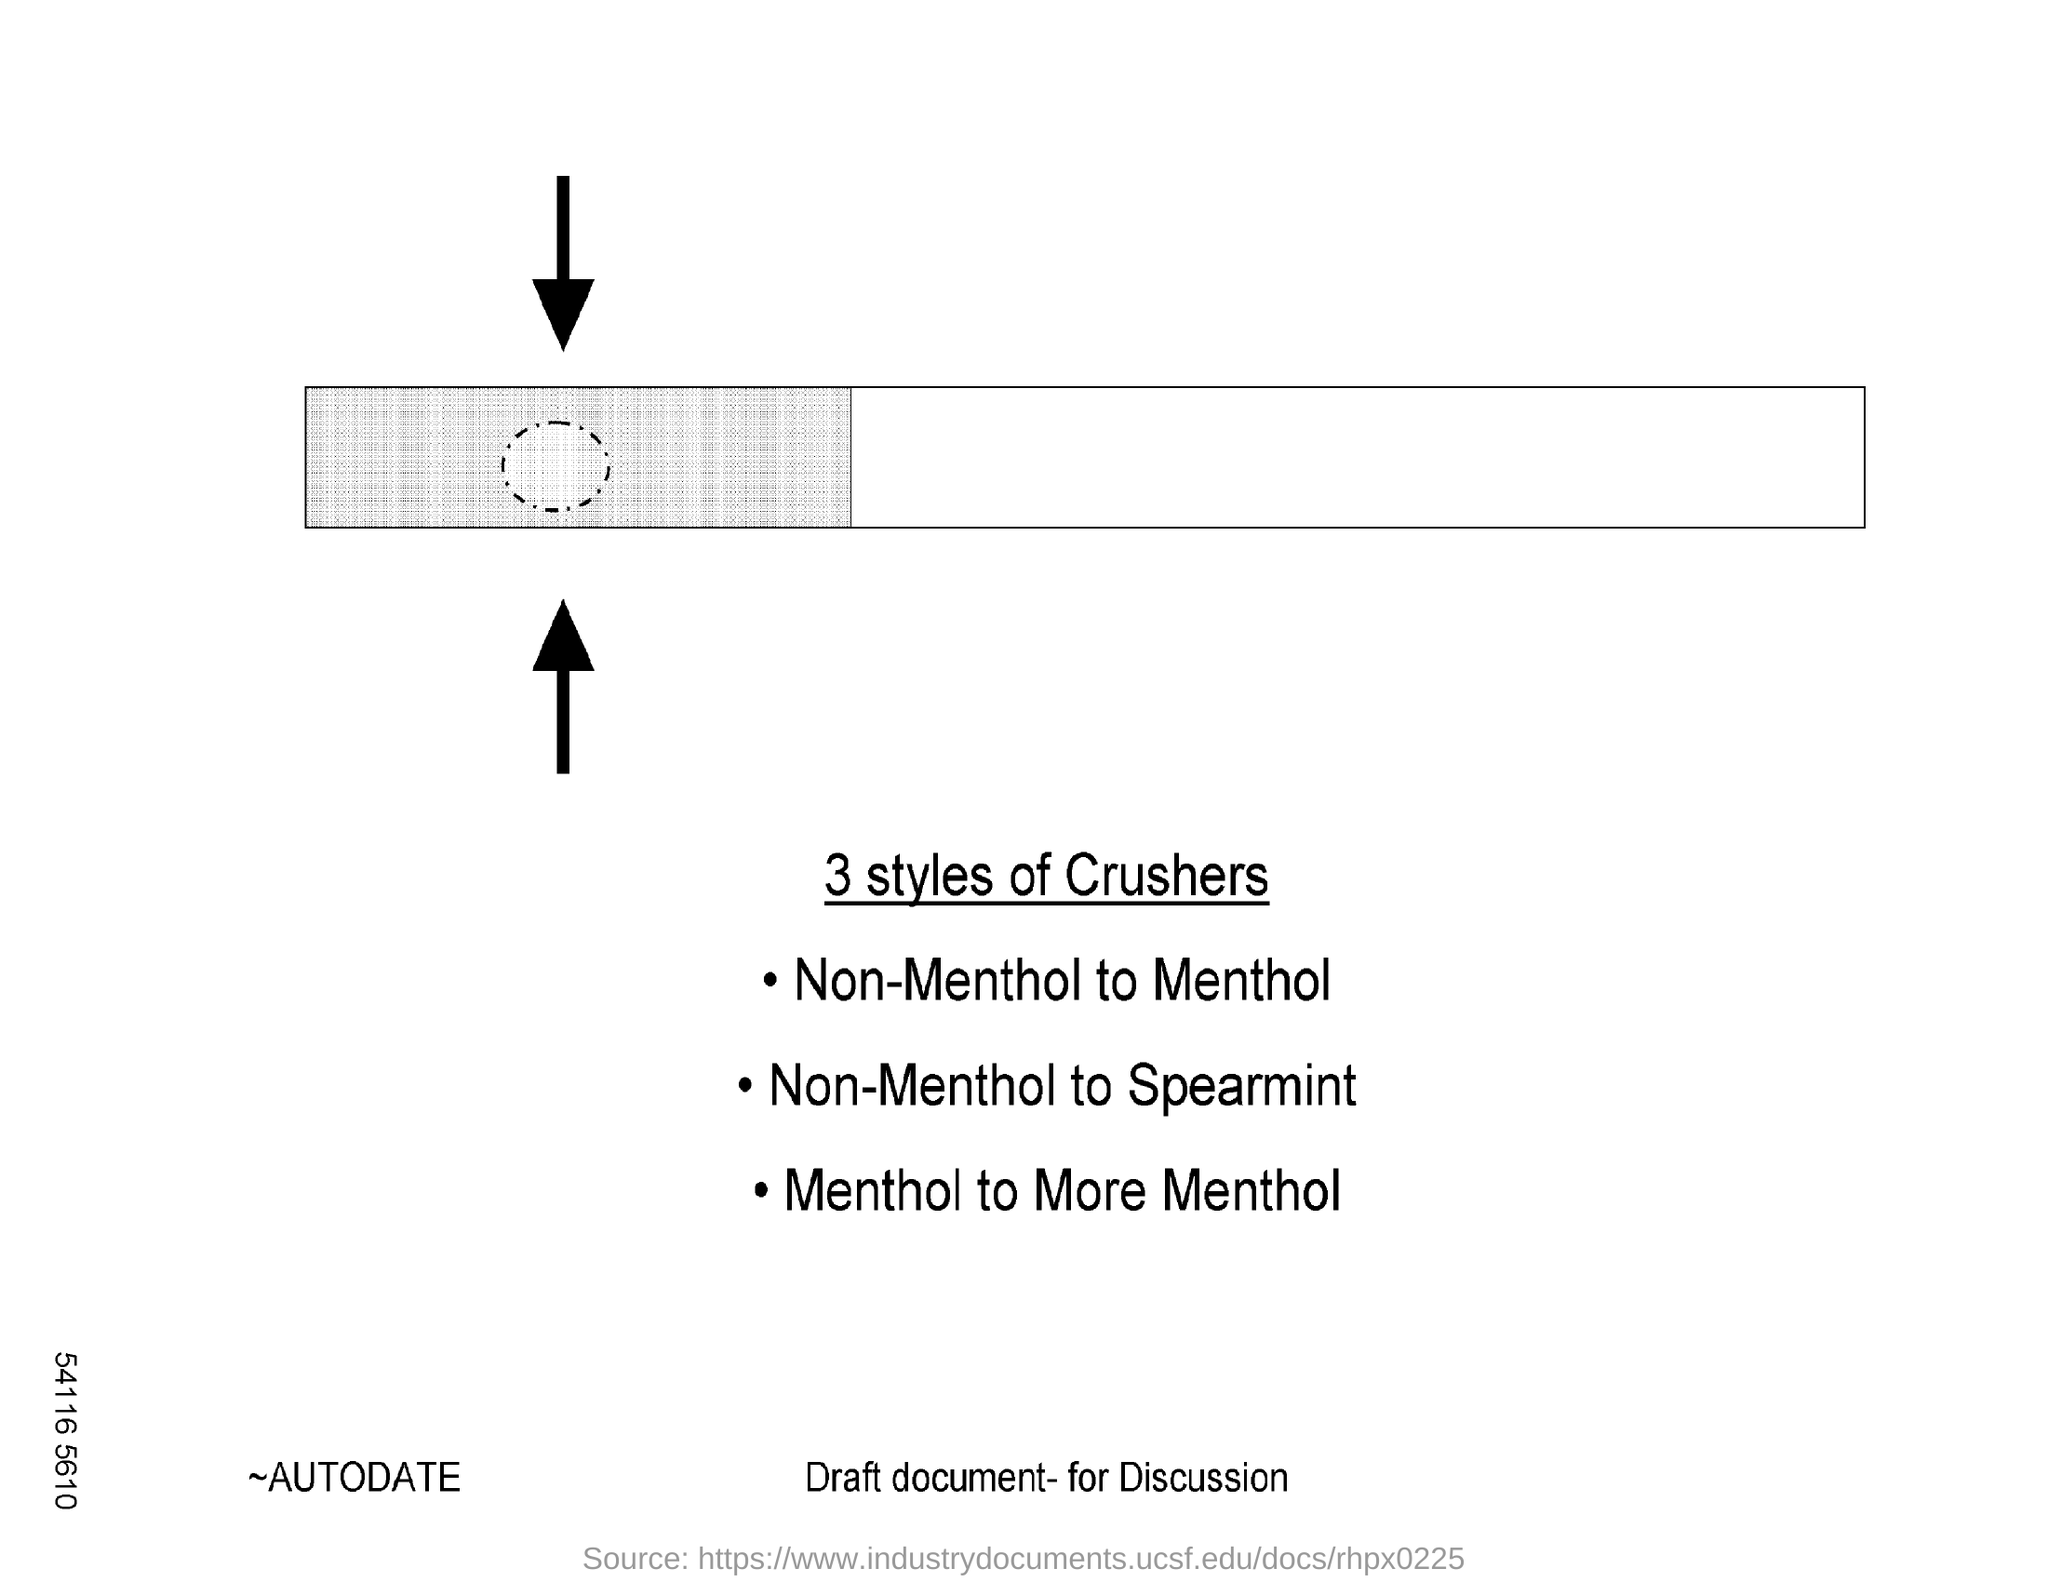List a handful of essential elements in this visual. The second style of crusher is non-menthol to spearmint. The first style of crusher is a non-menthol crusher, and the process of converting it to a menthol crusher involves the transfer of menthol from one substance to another. I have identified a third style of crusher, which involves increasing the menthol content of a product. Specifically, the process involves mentholating a product to more menthol, as compared to its original menthol content. 